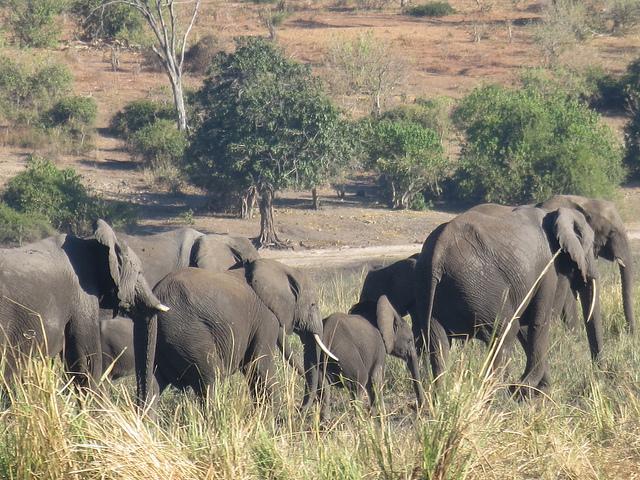What animals are shown?
Give a very brief answer. Elephants. How many babies in the picture?
Keep it brief. 1. Are they  all going the same way?
Answer briefly. Yes. How many elephants can be seen?
Write a very short answer. 6. 